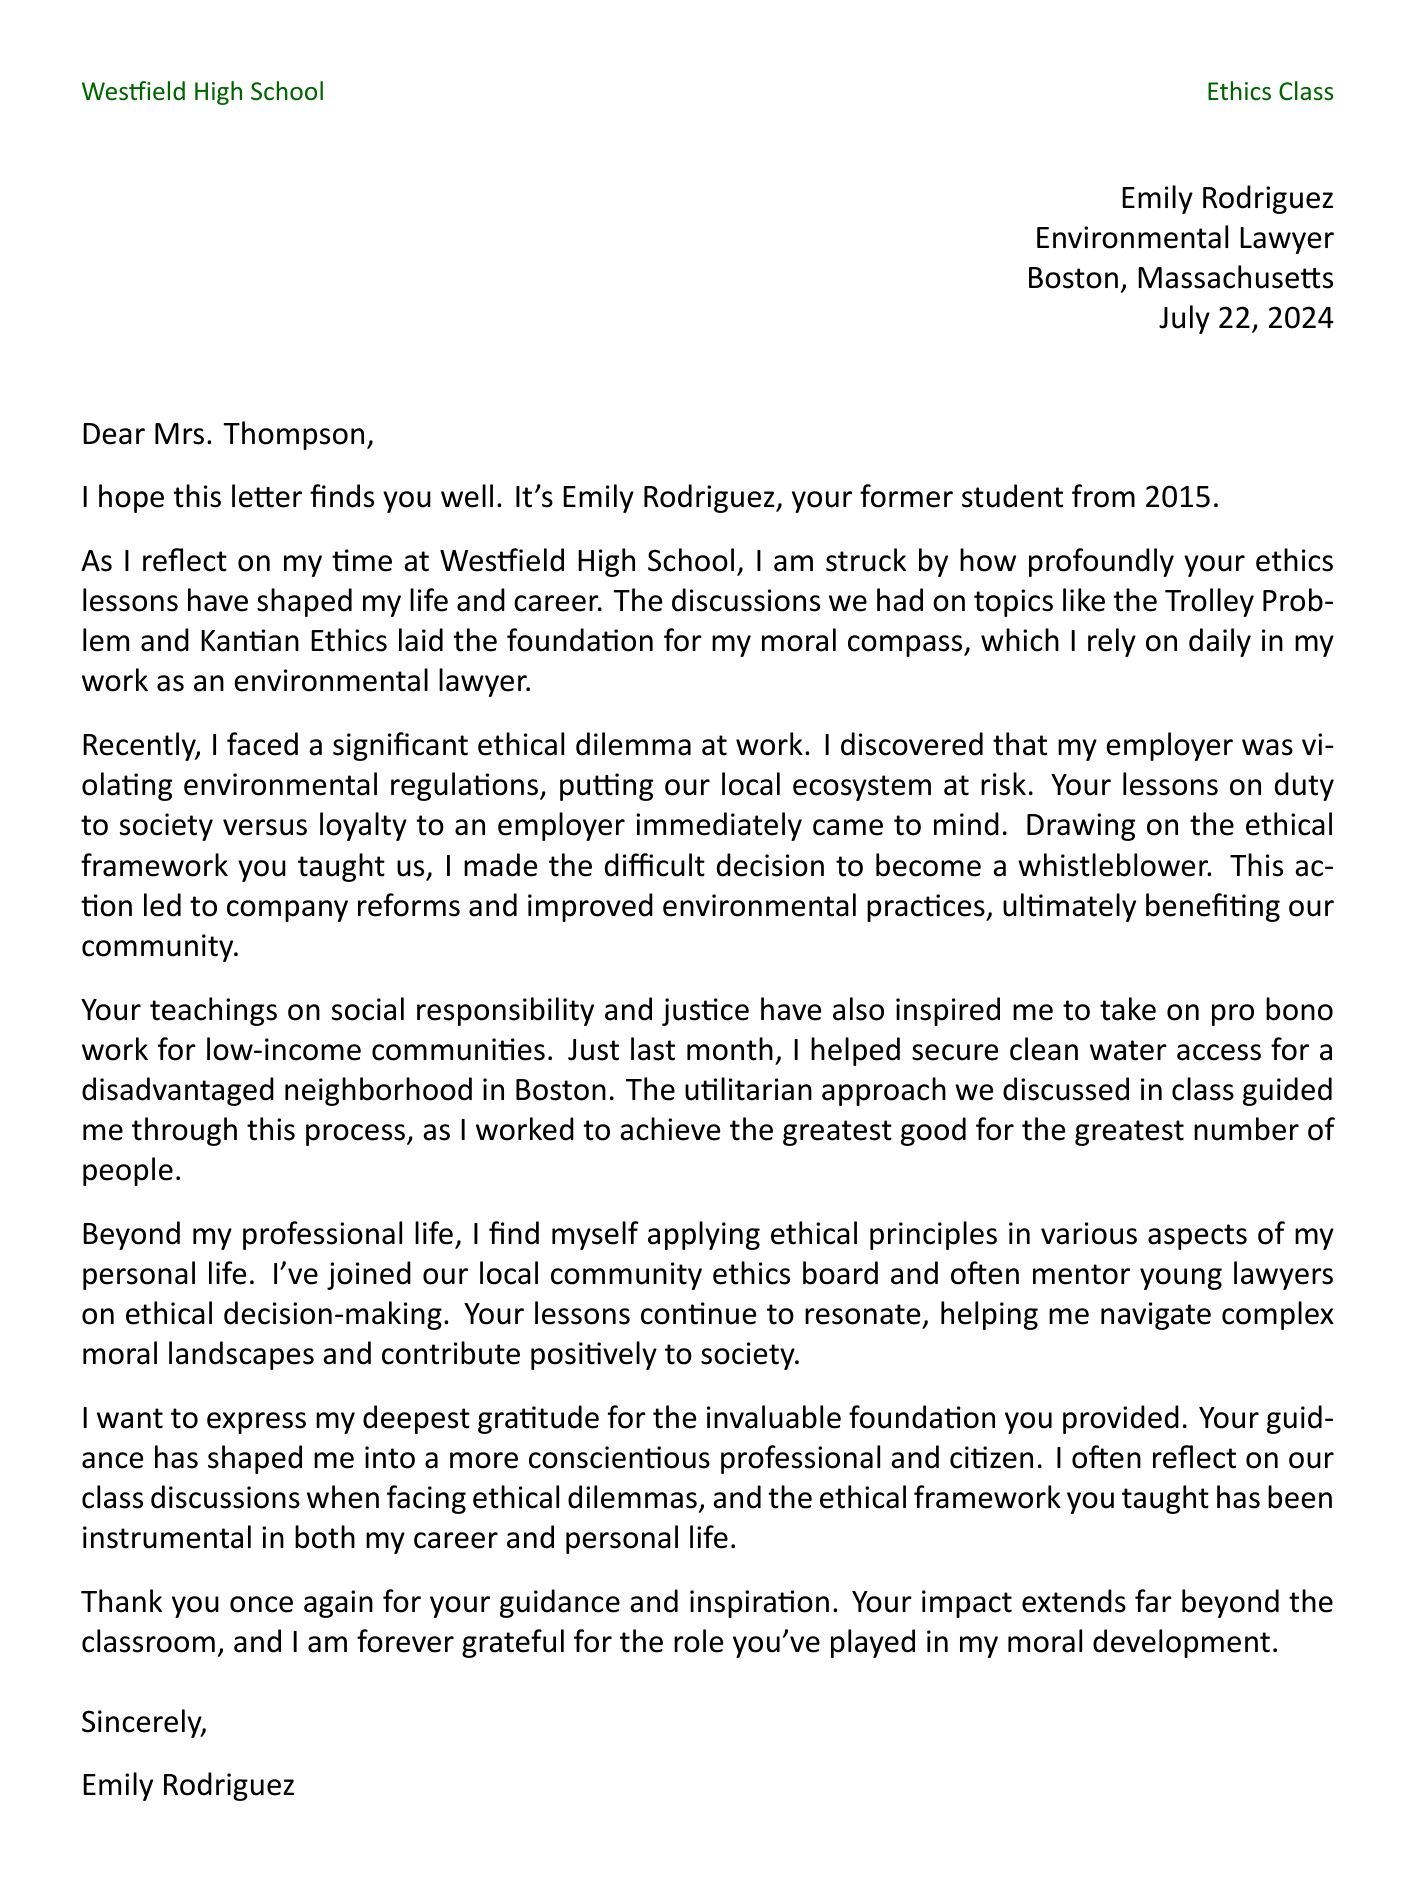What is the sender's name? The sender's name is the individual who wrote the letter, which is specified in the document as Emily Rodriguez.
Answer: Emily Rodriguez What year did the sender graduate? The graduation year is provided in the introduction of the document, stating that the sender graduated in 2015.
Answer: 2015 What is the sender's current occupation? The document explicitly mentions that the sender is an Environmental Lawyer.
Answer: Environmental Lawyer Which ethical principle guided the sender in their professional decision-making? The sender references the ethical principle of duty to society versus loyalty to an employer in their decision to whistleblow on environmental violations.
Answer: Duty to society vs. loyalty to employer What specific lesson does the sender attribute to preparing for ethical dilemmas? The sender reflects on the discussions regarding the Trolley Problem and Kantian Ethics as foundational for their moral compass.
Answer: The Trolley Problem and Kantian Ethics What community involvement is mentioned in the letter? The letter details the sender's participation in a local community ethics board, demonstrating ongoing ethical engagement.
Answer: Community ethics board How has the sender applied ethical lessons in personal life? The sender mentions mentoring young lawyers on ethical decision-making, showing how these lessons influence their personal interactions.
Answer: Mentoring young lawyers What is the sender's location? The letter specifies the current location of the sender, which is Boston, Massachusetts.
Answer: Boston, Massachusetts What is the conclusion of the letter? The conclusion expresses gratitude for the teacher's guidance and inspiration, forming a respectful end to the communication.
Answer: Thank you once again for your guidance and inspiration 